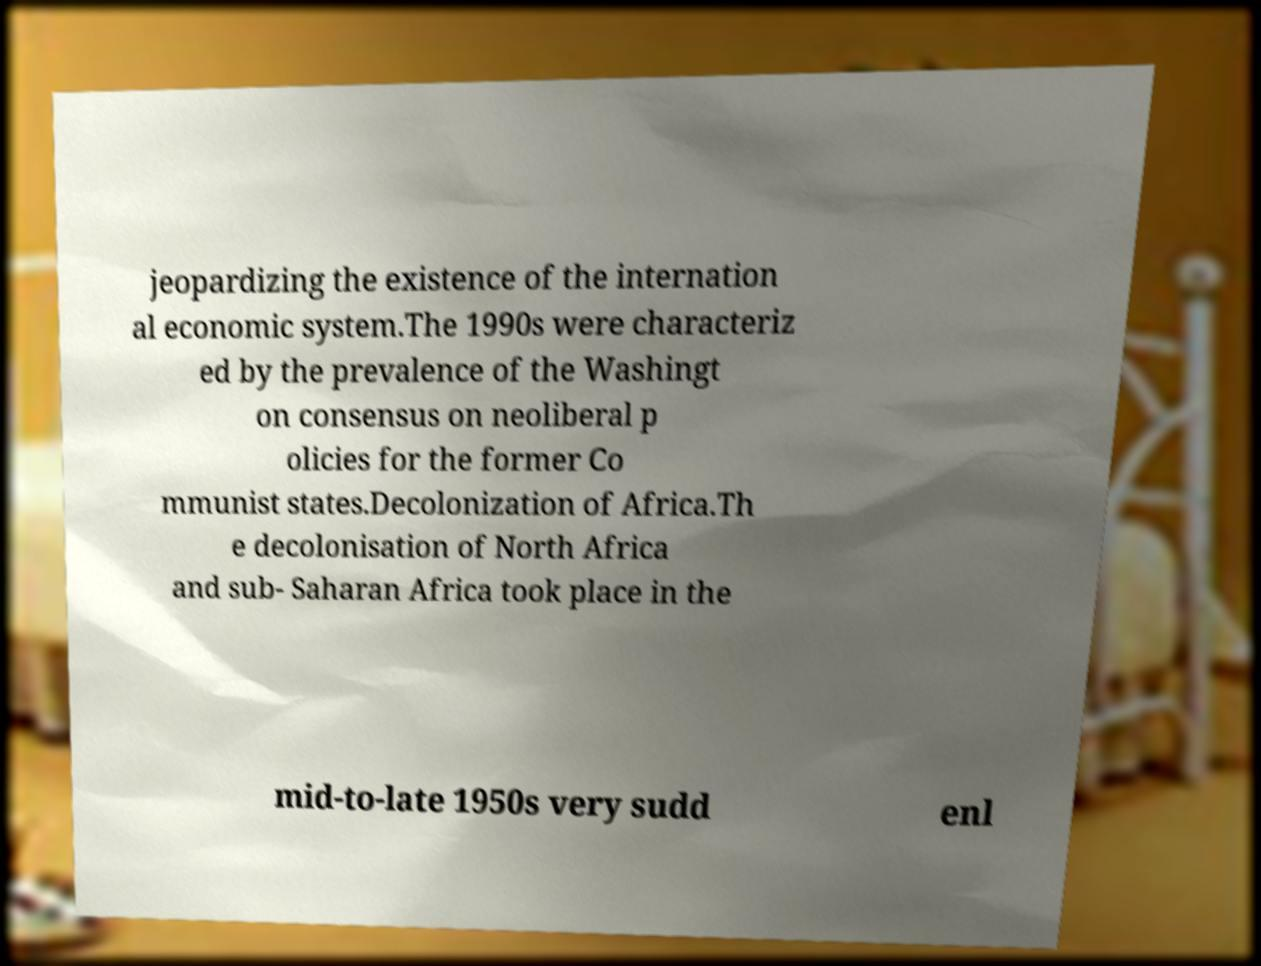What messages or text are displayed in this image? I need them in a readable, typed format. jeopardizing the existence of the internation al economic system.The 1990s were characteriz ed by the prevalence of the Washingt on consensus on neoliberal p olicies for the former Co mmunist states.Decolonization of Africa.Th e decolonisation of North Africa and sub- Saharan Africa took place in the mid-to-late 1950s very sudd enl 